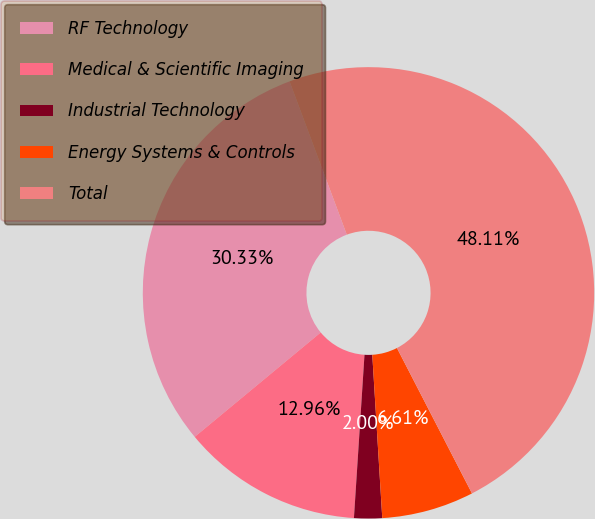Convert chart. <chart><loc_0><loc_0><loc_500><loc_500><pie_chart><fcel>RF Technology<fcel>Medical & Scientific Imaging<fcel>Industrial Technology<fcel>Energy Systems & Controls<fcel>Total<nl><fcel>30.33%<fcel>12.96%<fcel>2.0%<fcel>6.61%<fcel>48.11%<nl></chart> 